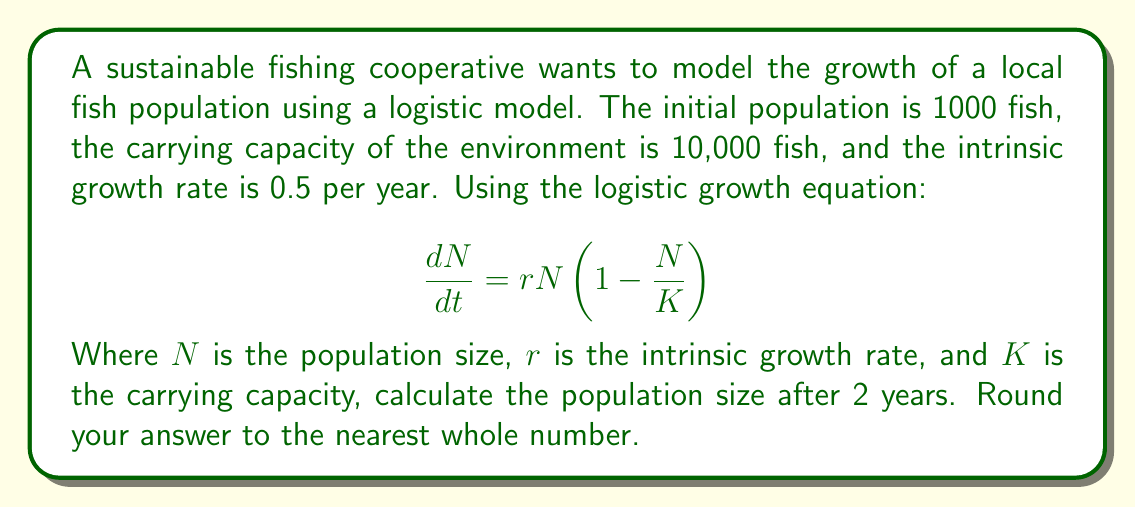Show me your answer to this math problem. To solve this problem, we need to use the solution to the logistic differential equation:

$$N(t) = \frac{K}{1 + (\frac{K}{N_0} - 1)e^{-rt}}$$

Where:
$N(t)$ is the population size at time $t$
$K$ is the carrying capacity (10,000)
$N_0$ is the initial population (1,000)
$r$ is the intrinsic growth rate (0.5)
$t$ is the time in years (2)

Let's substitute these values into the equation:

$$N(2) = \frac{10000}{1 + (\frac{10000}{1000} - 1)e^{-0.5 \cdot 2}}$$

$$= \frac{10000}{1 + (10 - 1)e^{-1}}$$

$$= \frac{10000}{1 + 9e^{-1}}$$

Now, let's calculate this step by step:

1. Calculate $e^{-1} \approx 0.3679$
2. Multiply: $9 \cdot 0.3679 \approx 3.3111$
3. Add 1: $1 + 3.3111 = 4.3111$
4. Divide: $10000 \div 4.3111 \approx 2319.8$

Rounding to the nearest whole number, we get 2320.
Answer: 2320 fish 